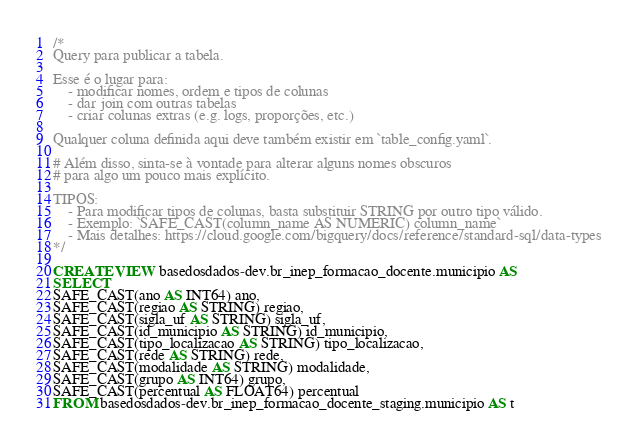Convert code to text. <code><loc_0><loc_0><loc_500><loc_500><_SQL_>/*
Query para publicar a tabela.

Esse é o lugar para:
    - modificar nomes, ordem e tipos de colunas
    - dar join com outras tabelas
    - criar colunas extras (e.g. logs, proporções, etc.)

Qualquer coluna definida aqui deve também existir em `table_config.yaml`.

# Além disso, sinta-se à vontade para alterar alguns nomes obscuros
# para algo um pouco mais explícito.

TIPOS:
    - Para modificar tipos de colunas, basta substituir STRING por outro tipo válido.
    - Exemplo: `SAFE_CAST(column_name AS NUMERIC) column_name`
    - Mais detalhes: https://cloud.google.com/bigquery/docs/reference/standard-sql/data-types
*/

CREATE VIEW basedosdados-dev.br_inep_formacao_docente.municipio AS
SELECT 
SAFE_CAST(ano AS INT64) ano,
SAFE_CAST(regiao AS STRING) regiao,
SAFE_CAST(sigla_uf AS STRING) sigla_uf,
SAFE_CAST(id_municipio AS STRING) id_municipio,
SAFE_CAST(tipo_localizacao AS STRING) tipo_localizacao,
SAFE_CAST(rede AS STRING) rede,
SAFE_CAST(modalidade AS STRING) modalidade,
SAFE_CAST(grupo AS INT64) grupo,
SAFE_CAST(percentual AS FLOAT64) percentual
FROM basedosdados-dev.br_inep_formacao_docente_staging.municipio AS t</code> 